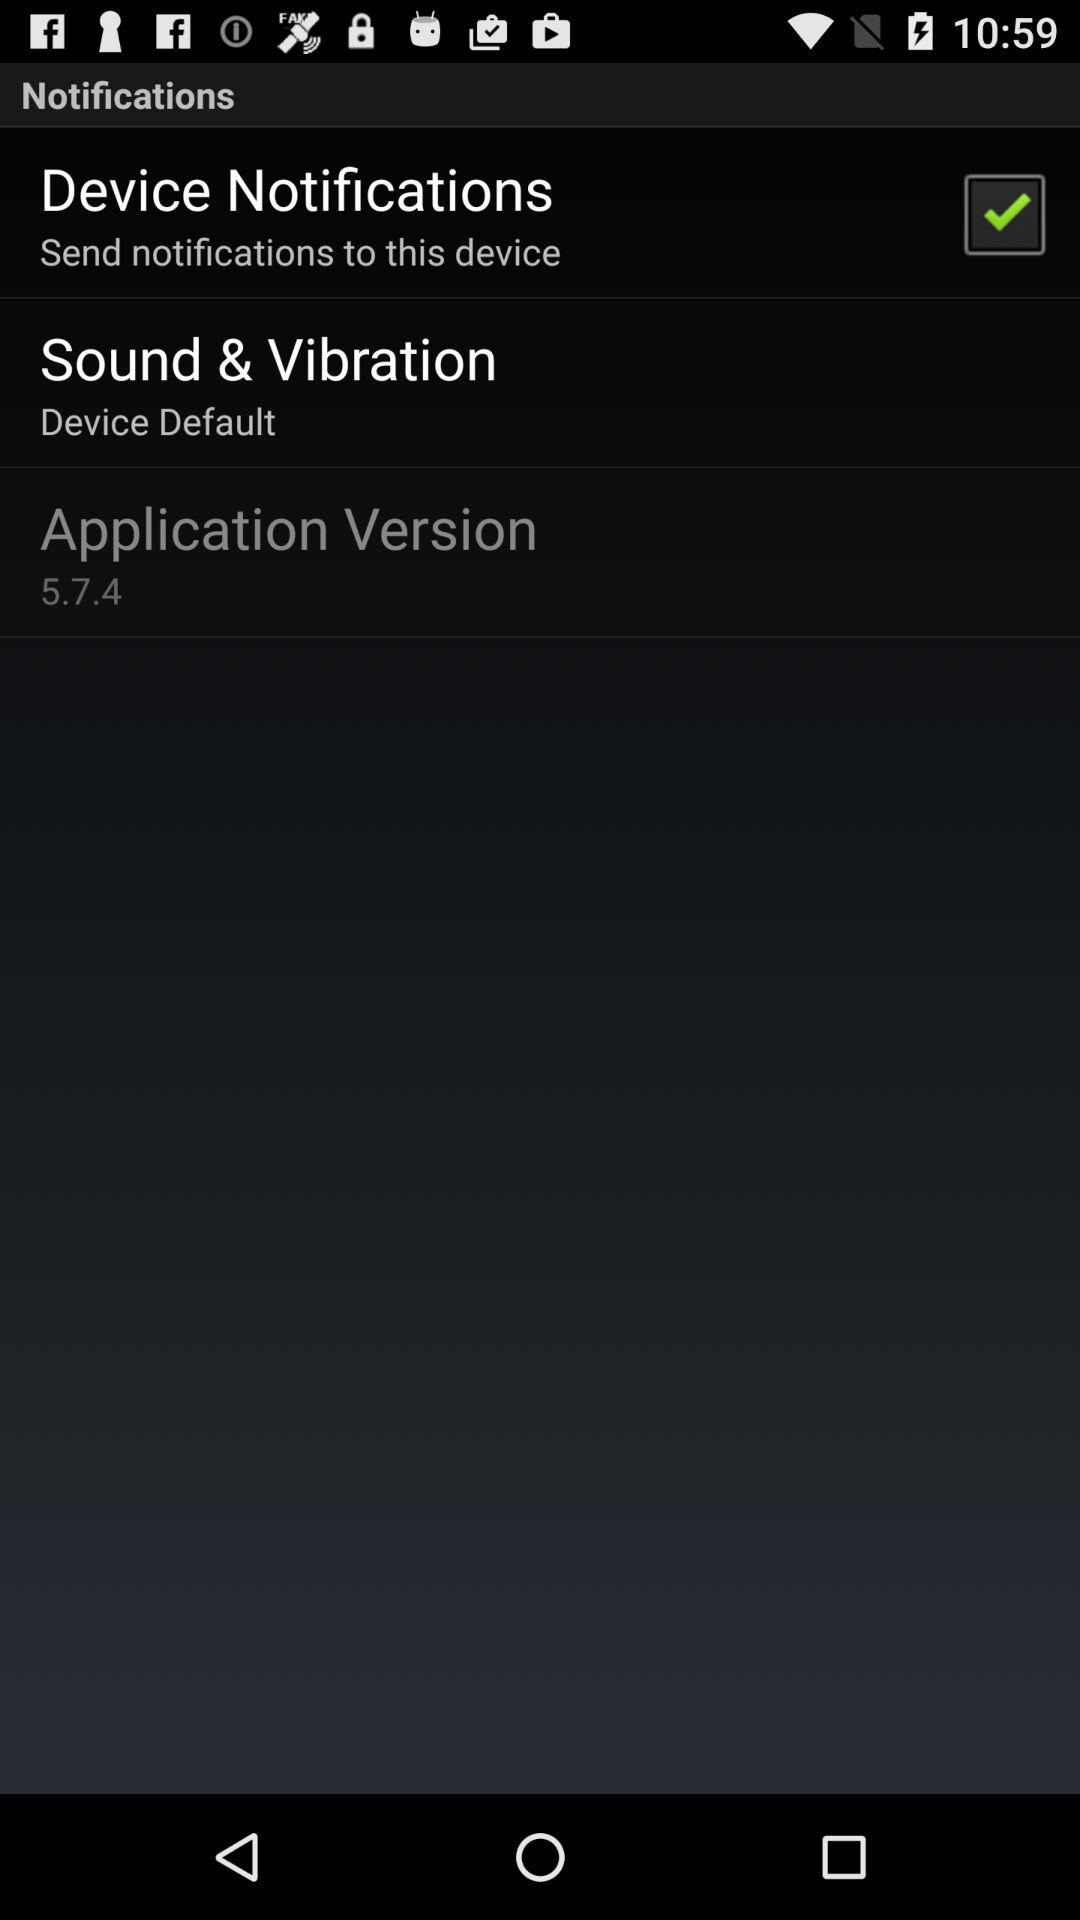What is the version of the application?
Answer the question using a single word or phrase. 5.7.4 